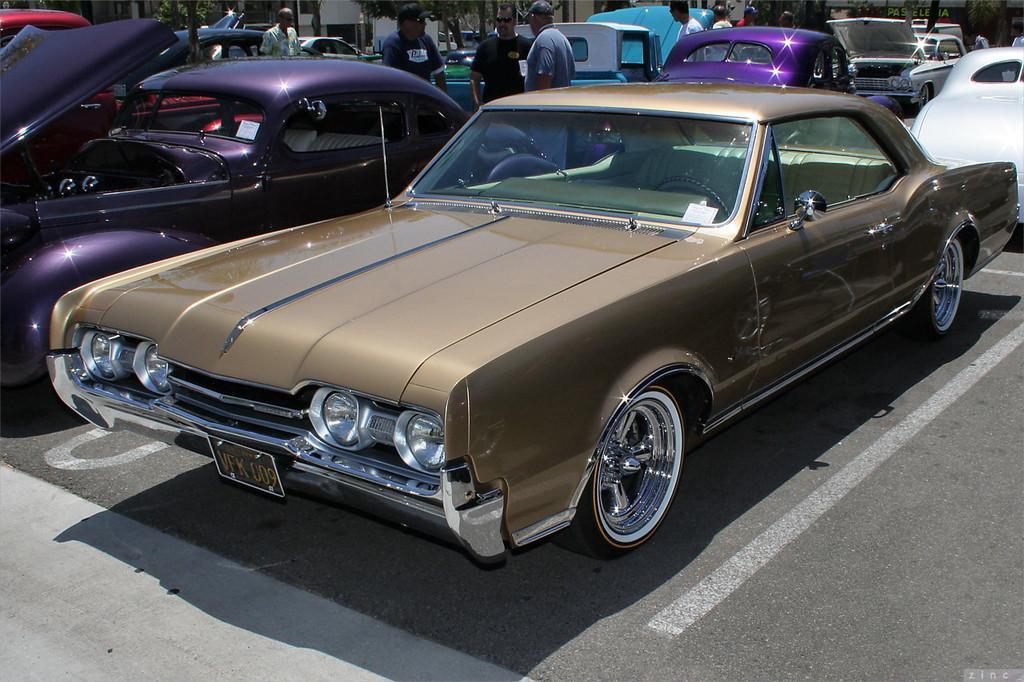Can you describe this image briefly? Here we can see cars on the road. In the background there are few persons standing on the road,trees,buildings,hoarding and some other objects. 